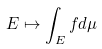<formula> <loc_0><loc_0><loc_500><loc_500>E \mapsto \int _ { E } f d \mu</formula> 